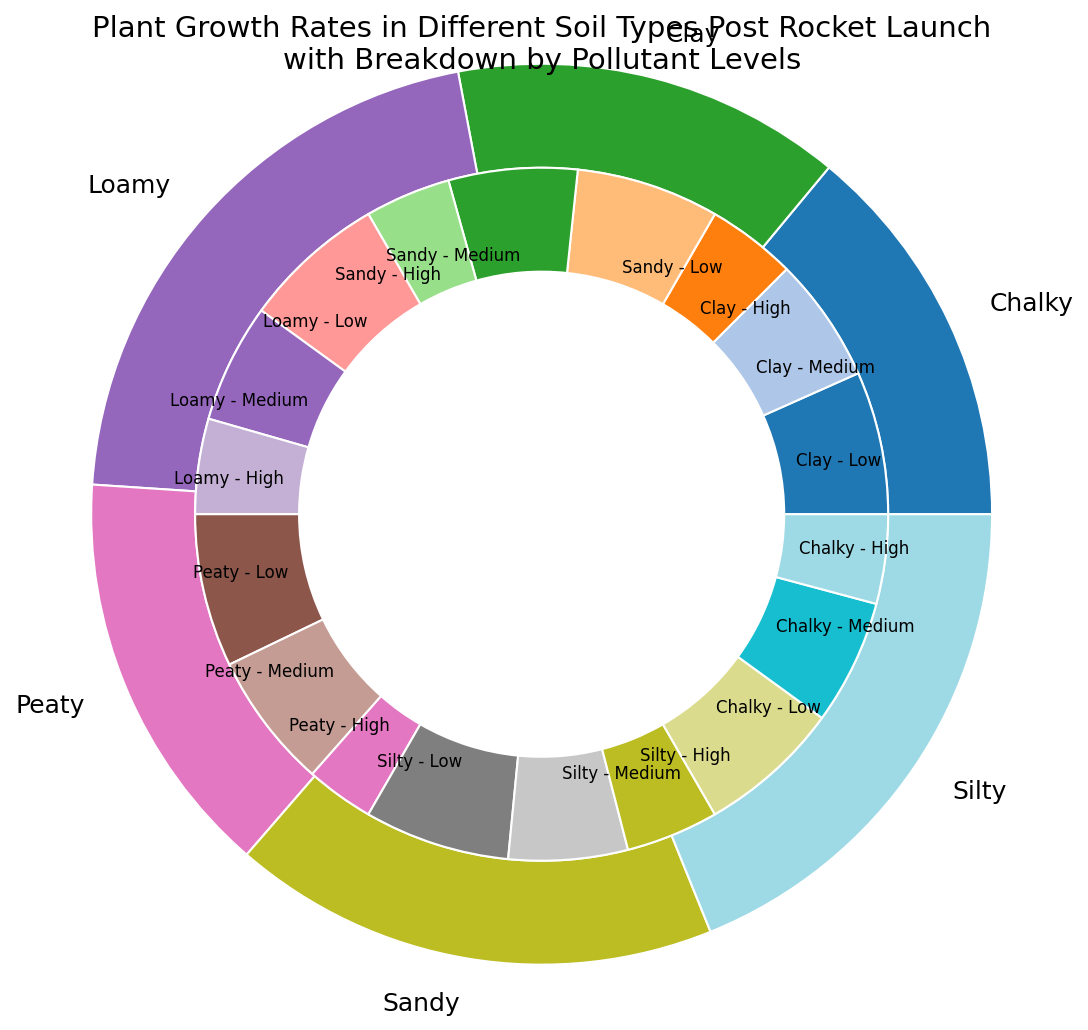Which soil type has the highest overall plant growth rate? The outer ring of the nested pie chart represents the total plant growth rate for each soil type. The soil type with the largest segment in the outer ring has the highest overall growth rate.
Answer: Loamy Which pollutant level leads to the lowest plant growth rate in Sandy soil? The inner ring segments representing Sandy soil can be compared. The segment labeled "Sandy - High" is the smallest among the Sandy segments, indicating the lowest growth rate.
Answer: High How does the plant growth rate in Peaty soil under low pollutant levels compare to that in Chalky soil under the same conditions? Look at the inner ring segments labeled "Peaty - Low" and "Chalky - Low". The size of the "Peaty - Low" segment is larger than the "Chalky - Low" segment, indicating that Peaty soil under low pollutant levels has a higher growth rate.
Answer: Peaty soil has a higher growth rate What is the difference in plant growth rates between Clay soil with medium pollutant levels and Silty soil with high pollutant levels? The inner ring segments labeled "Clay - Medium" and "Silty - High" represent the respective growth rates. Clay - Medium is 7 and Silty - High is 7. Subtracting Silty - High from Clay - Medium gives a difference of 0.
Answer: 0 Which soil type shows the most even distribution of growth rates across different pollutant levels? Examine the inner ring segments for each soil type. The soil type whose segments are closest in size indicates an even distribution.
Answer: Clay How does the plant growth rate in Loamy soil under medium pollutant levels compare to the overall growth rate in Silty soil? Compare the inner ring segment for "Loamy - Medium" with the outer ring segment for Silty. "Loamy - Medium" is 10, and the total for Silty is 27.
Answer: Loamy - Medium is lower What soil type under high pollutant levels has the highest plant growth rate? From the inner ring, find the largest segment labeled with a pollutant level of 'High'.
Answer: Loamy Is the overall growth rate for Chalky soil higher or lower than for Clay soil? Compare the outer ring segments for Chalky and Clay. The Chalky segment should be smaller than the Clay segment.
Answer: Lower 